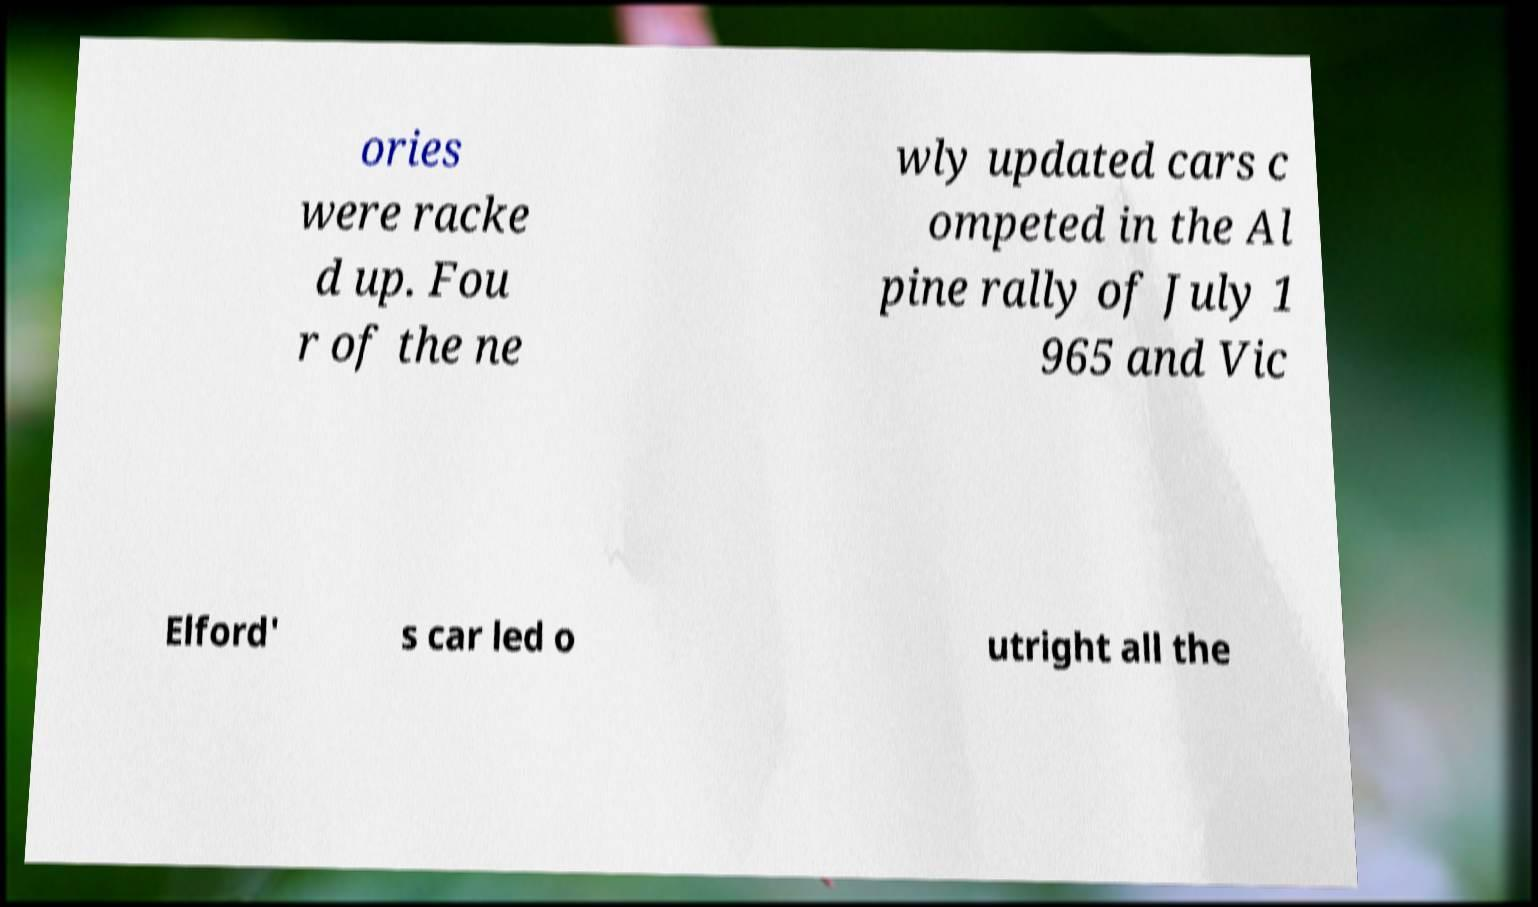There's text embedded in this image that I need extracted. Can you transcribe it verbatim? ories were racke d up. Fou r of the ne wly updated cars c ompeted in the Al pine rally of July 1 965 and Vic Elford' s car led o utright all the 